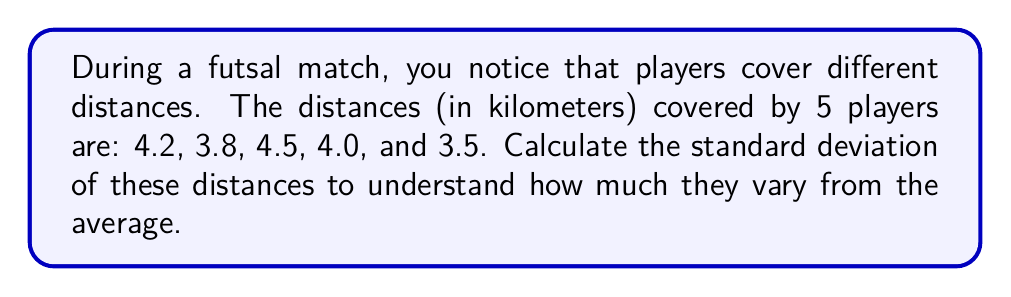Solve this math problem. To calculate the standard deviation, we'll follow these steps:

1. Calculate the mean (average) distance:
   $$\bar{x} = \frac{4.2 + 3.8 + 4.5 + 4.0 + 3.5}{5} = 4$$

2. Calculate the squared differences from the mean:
   $$(4.2 - 4)^2 = 0.04$$
   $$(3.8 - 4)^2 = 0.04$$
   $$(4.5 - 4)^2 = 0.25$$
   $$(4.0 - 4)^2 = 0$$
   $$(3.5 - 4)^2 = 0.25$$

3. Calculate the average of these squared differences:
   $$\frac{0.04 + 0.04 + 0.25 + 0 + 0.25}{5} = 0.116$$

4. Take the square root of this average to get the standard deviation:
   $$\sqrt{0.116} \approx 0.3405$$

Therefore, the standard deviation of the distances covered by the players is approximately 0.3405 km.
Answer: 0.3405 km 